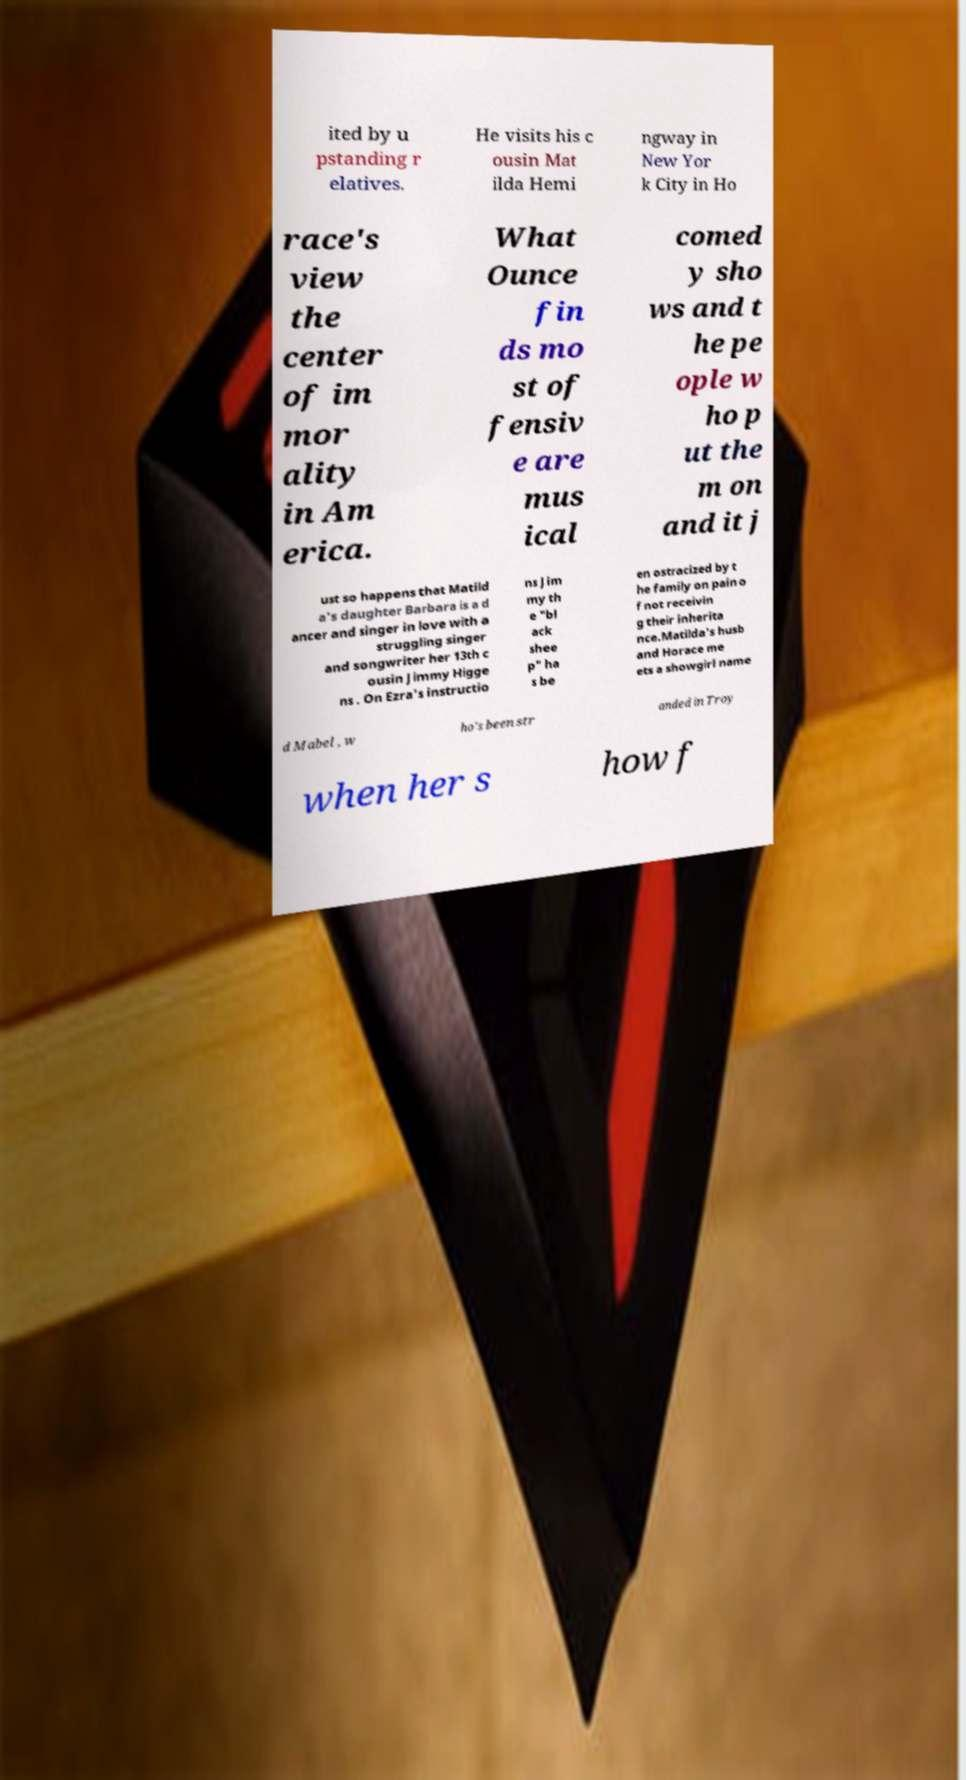For documentation purposes, I need the text within this image transcribed. Could you provide that? ited by u pstanding r elatives. He visits his c ousin Mat ilda Hemi ngway in New Yor k City in Ho race's view the center of im mor ality in Am erica. What Ounce fin ds mo st of fensiv e are mus ical comed y sho ws and t he pe ople w ho p ut the m on and it j ust so happens that Matild a's daughter Barbara is a d ancer and singer in love with a struggling singer and songwriter her 13th c ousin Jimmy Higge ns . On Ezra's instructio ns Jim my th e "bl ack shee p" ha s be en ostracized by t he family on pain o f not receivin g their inherita nce.Matilda's husb and Horace me ets a showgirl name d Mabel , w ho's been str anded in Troy when her s how f 